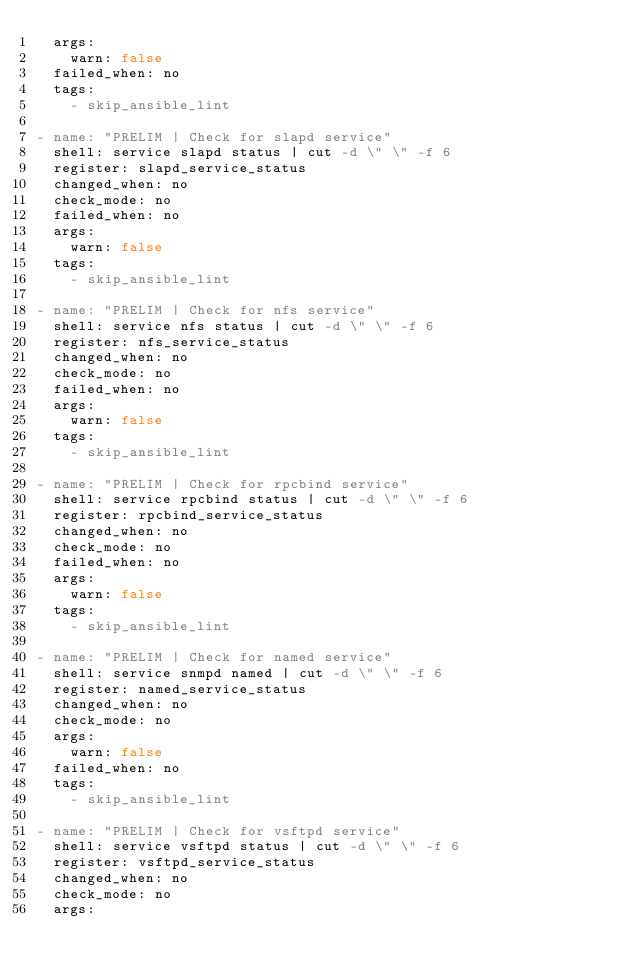<code> <loc_0><loc_0><loc_500><loc_500><_YAML_>  args:
    warn: false
  failed_when: no
  tags:
    - skip_ansible_lint

- name: "PRELIM | Check for slapd service"
  shell: service slapd status | cut -d \" \" -f 6
  register: slapd_service_status
  changed_when: no
  check_mode: no
  failed_when: no
  args:
    warn: false
  tags:
    - skip_ansible_lint

- name: "PRELIM | Check for nfs service"
  shell: service nfs status | cut -d \" \" -f 6
  register: nfs_service_status
  changed_when: no
  check_mode: no
  failed_when: no
  args:
    warn: false
  tags:
    - skip_ansible_lint

- name: "PRELIM | Check for rpcbind service"
  shell: service rpcbind status | cut -d \" \" -f 6
  register: rpcbind_service_status
  changed_when: no
  check_mode: no
  failed_when: no
  args:
    warn: false
  tags:
    - skip_ansible_lint

- name: "PRELIM | Check for named service"
  shell: service snmpd named | cut -d \" \" -f 6
  register: named_service_status
  changed_when: no
  check_mode: no
  args:
    warn: false
  failed_when: no
  tags:
    - skip_ansible_lint

- name: "PRELIM | Check for vsftpd service"
  shell: service vsftpd status | cut -d \" \" -f 6
  register: vsftpd_service_status
  changed_when: no
  check_mode: no
  args:</code> 